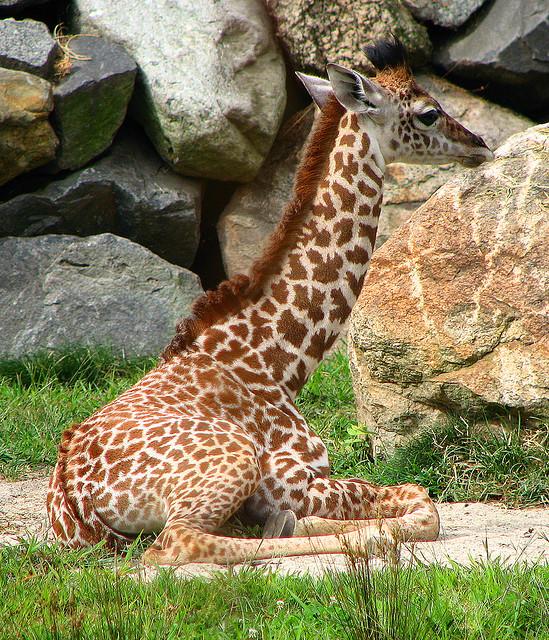How many giraffes are present?
Concise answer only. 1. Is the giraffe laying on the grass?
Short answer required. No. What is the giraffe doing?
Short answer required. Sitting. How many giraffes are in the photo?
Answer briefly. 1. How many giraffes are in the picture?
Answer briefly. 1. What color is the giraffe?
Quick response, please. Brown and white. Is the animal laying down?
Write a very short answer. Yes. 